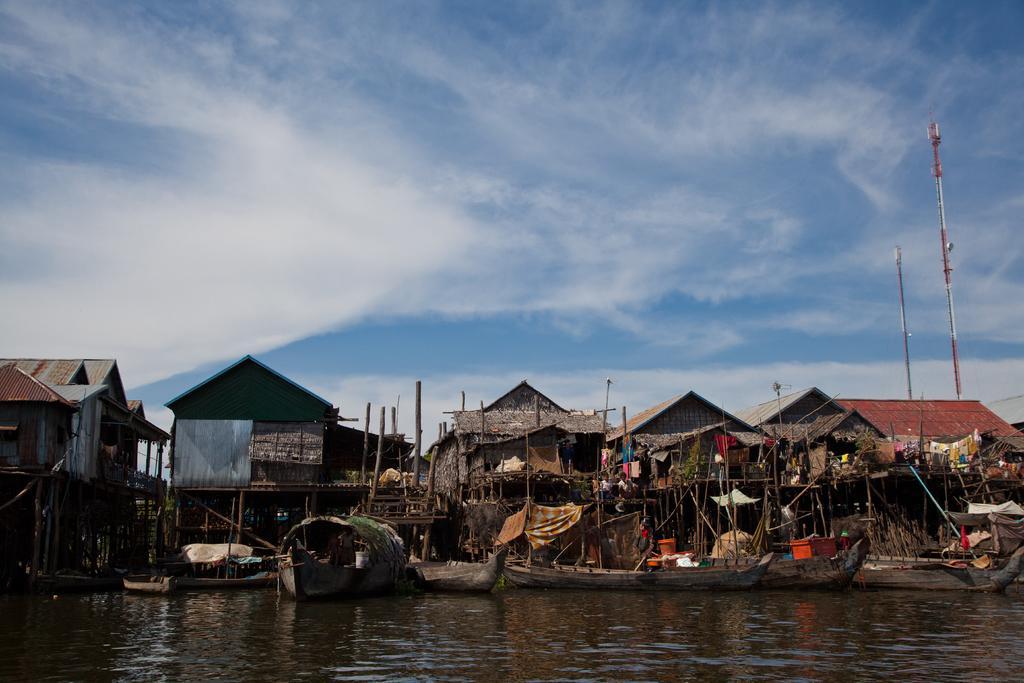Please provide a concise description of this image. In this picture we can observe some houses and some boats on the water. We can observe two poles on the right side. In the background there is a sky with some clouds. 